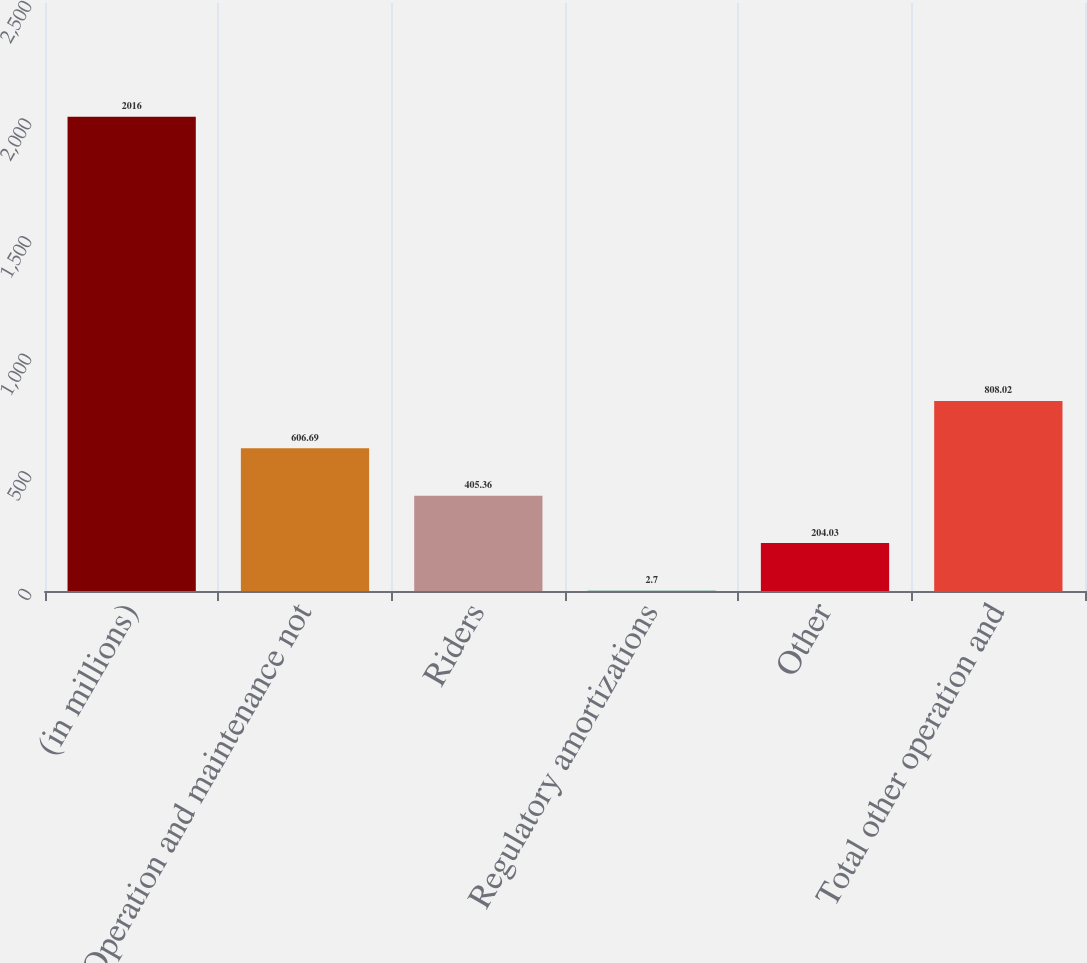Convert chart to OTSL. <chart><loc_0><loc_0><loc_500><loc_500><bar_chart><fcel>(in millions)<fcel>Operation and maintenance not<fcel>Riders<fcel>Regulatory amortizations<fcel>Other<fcel>Total other operation and<nl><fcel>2016<fcel>606.69<fcel>405.36<fcel>2.7<fcel>204.03<fcel>808.02<nl></chart> 